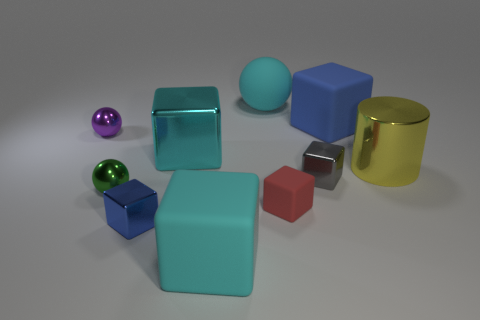What material is the cyan thing behind the big matte block that is behind the cyan matte object in front of the big cyan rubber sphere made of?
Offer a very short reply. Rubber. What number of other things are the same shape as the tiny gray thing?
Offer a terse response. 5. What color is the large rubber cube that is behind the gray cube?
Keep it short and to the point. Blue. How many green metal things are in front of the large rubber object that is in front of the cube that is right of the small gray metallic block?
Keep it short and to the point. 0. What number of yellow cylinders are to the left of the cyan rubber thing that is in front of the purple metallic ball?
Your answer should be very brief. 0. There is a small red rubber object; what number of tiny metallic cubes are right of it?
Provide a short and direct response. 1. How many other objects are there of the same size as the yellow object?
Provide a short and direct response. 4. There is another cyan thing that is the same shape as the cyan shiny object; what is its size?
Give a very brief answer. Large. There is a small object behind the large yellow cylinder; what shape is it?
Offer a very short reply. Sphere. What is the color of the large rubber cube that is in front of the small cube that is to the left of the large cyan shiny cube?
Provide a short and direct response. Cyan. 